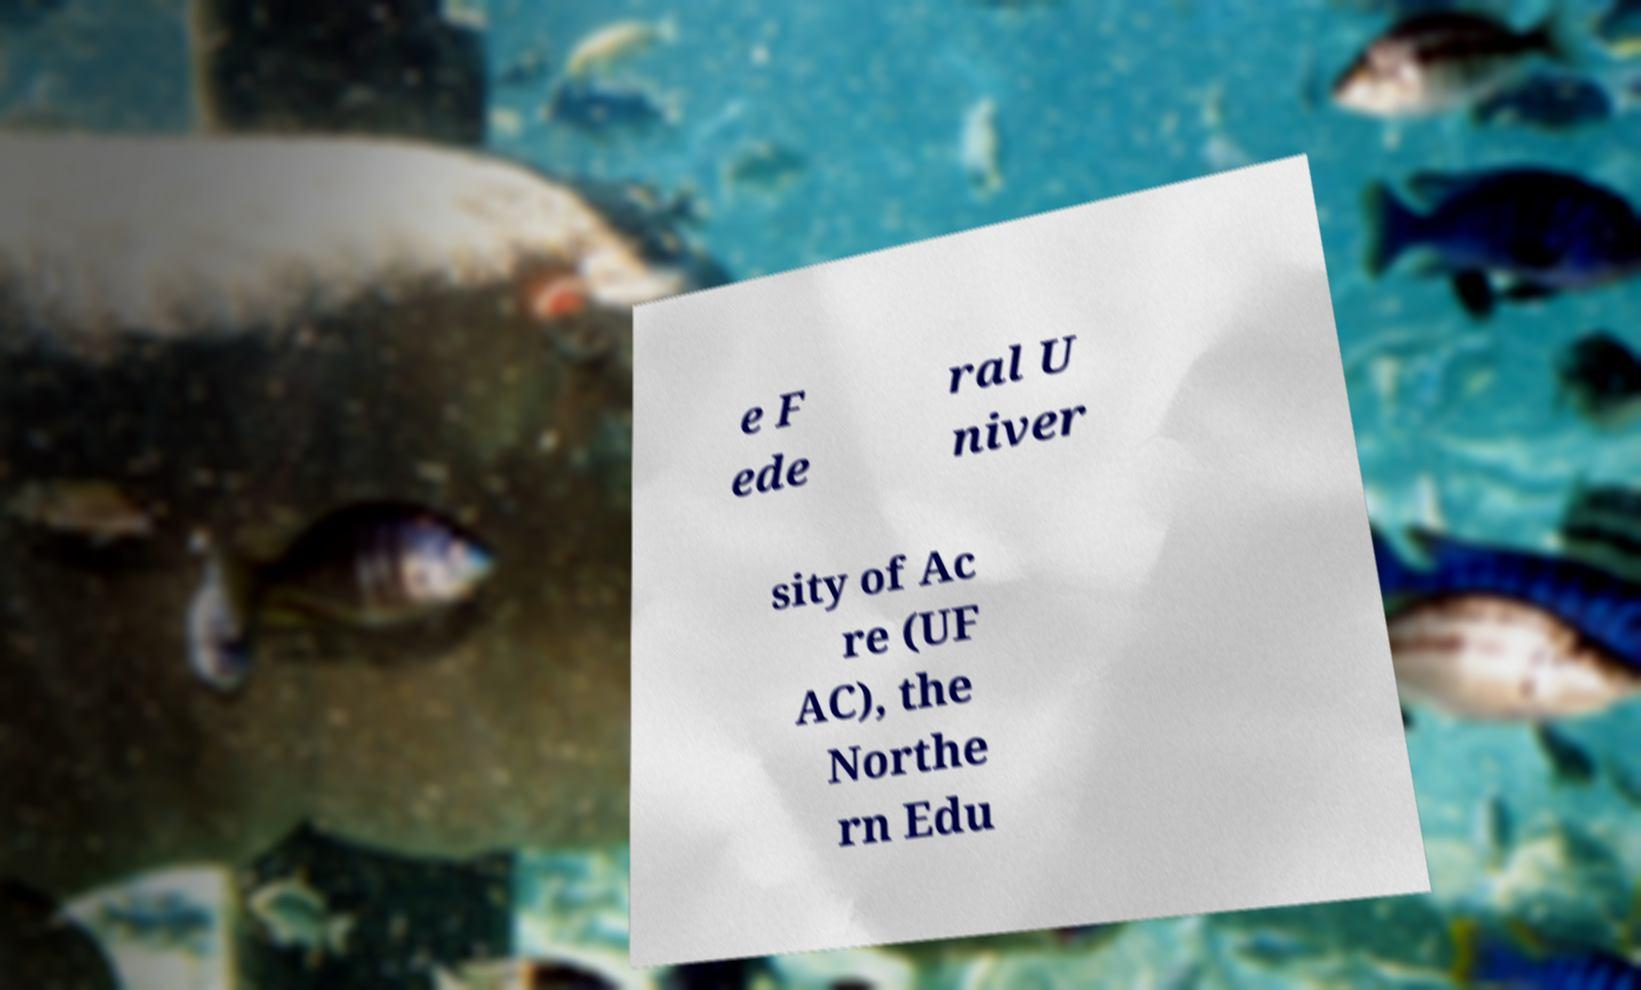Please identify and transcribe the text found in this image. e F ede ral U niver sity of Ac re (UF AC), the Northe rn Edu 